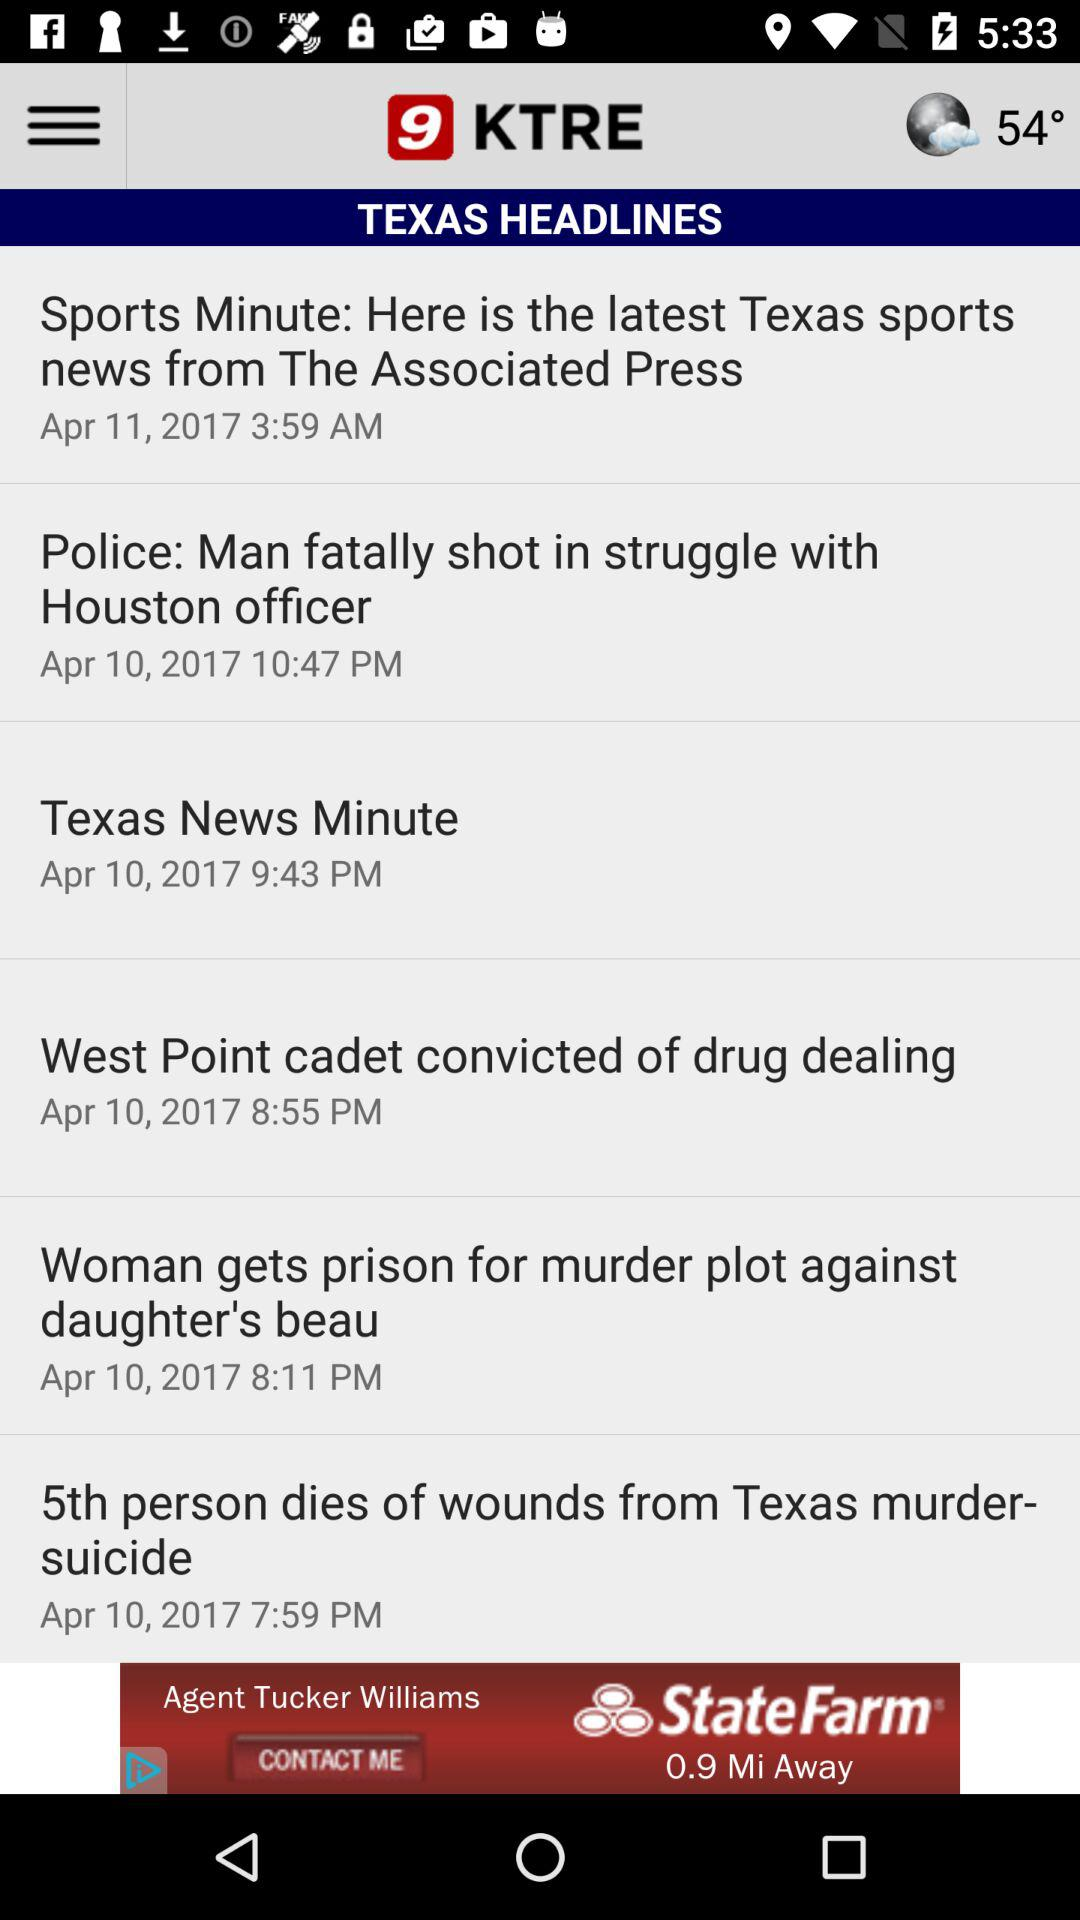Which news was published on April 10, 2017 at 7:59 p.m.? The news "5th person dies of wounds from Texas murder- suicide" was published on April 10, 2017 at 7:59 p.m. 